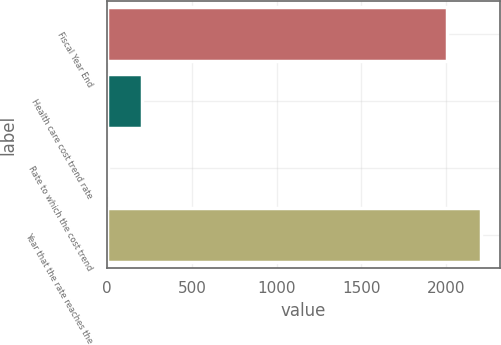Convert chart to OTSL. <chart><loc_0><loc_0><loc_500><loc_500><bar_chart><fcel>Fiscal Year End<fcel>Health care cost trend rate<fcel>Rate to which the cost trend<fcel>Year that the rate reaches the<nl><fcel>2005<fcel>205.68<fcel>5.2<fcel>2205.48<nl></chart> 